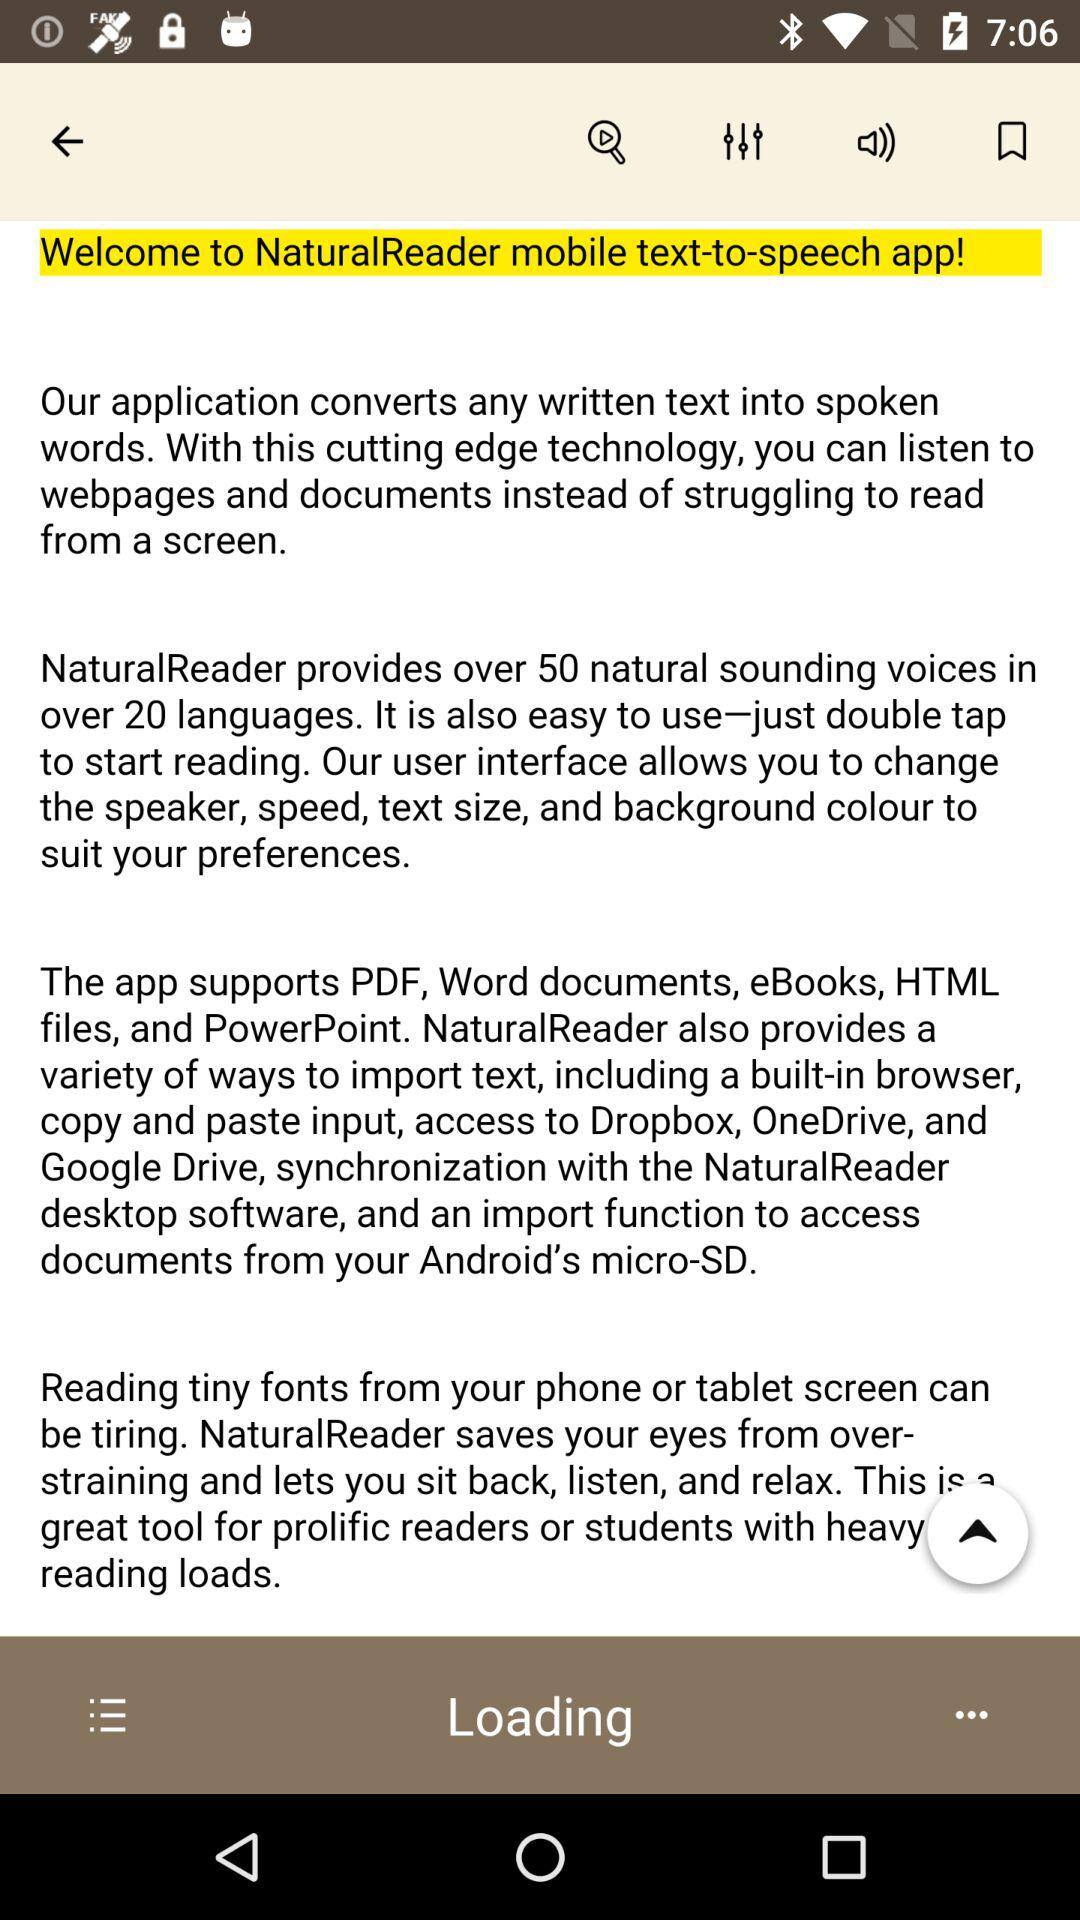How many natural-sounding voices are provided by "NaturalReader"? There are over 50 natural-sounding voices provided by "NaturalReader". 